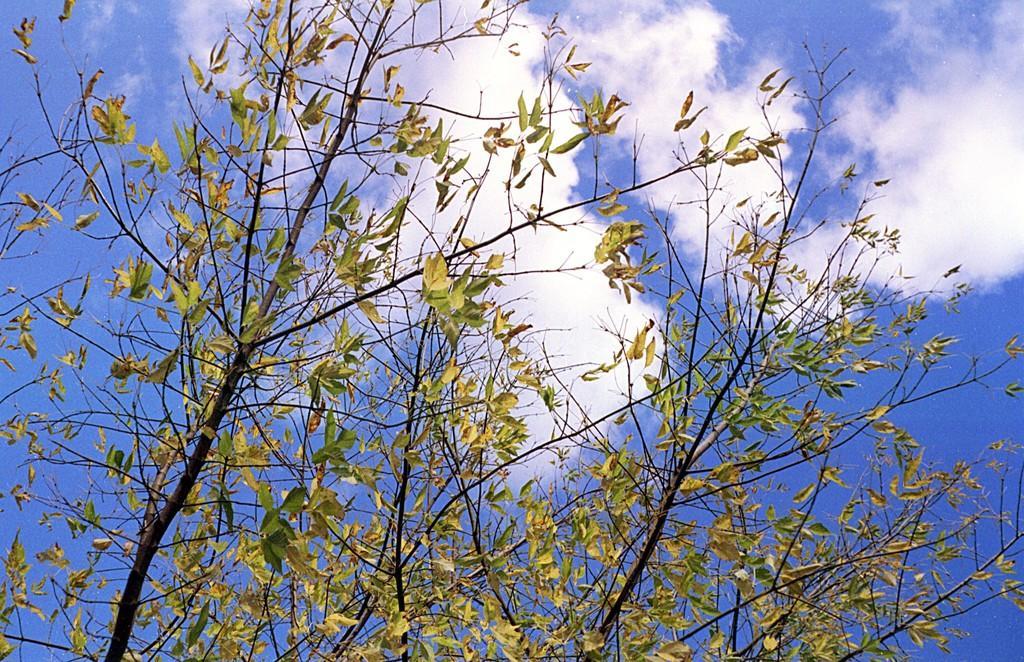Could you give a brief overview of what you see in this image? Here we can see a tree and clouds in the sky. 